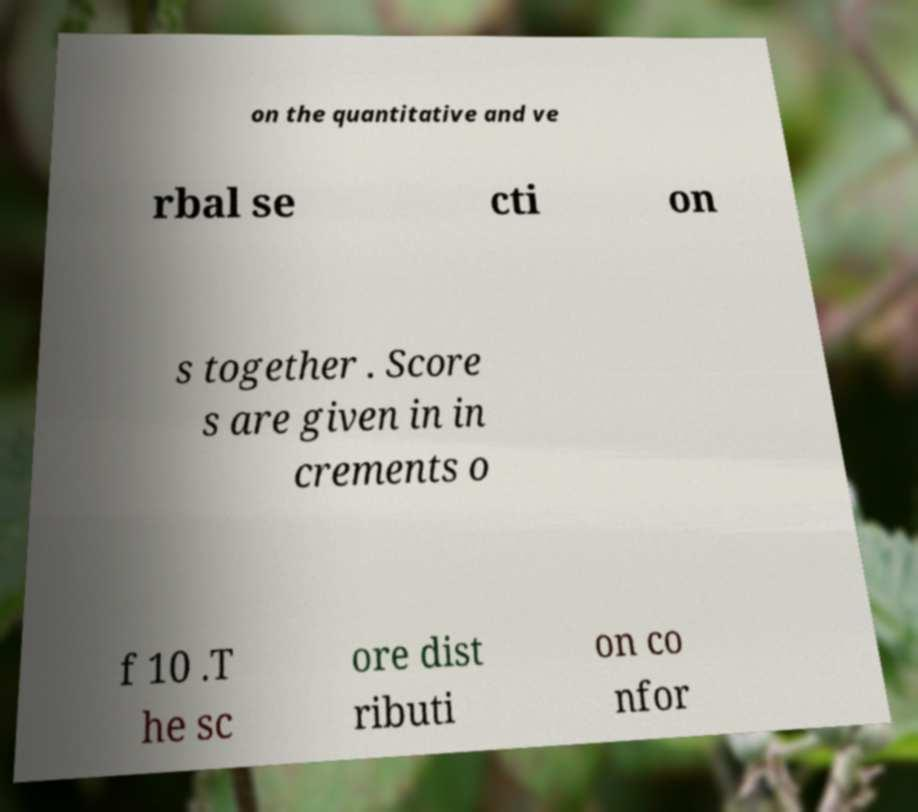Can you read and provide the text displayed in the image?This photo seems to have some interesting text. Can you extract and type it out for me? on the quantitative and ve rbal se cti on s together . Score s are given in in crements o f 10 .T he sc ore dist ributi on co nfor 